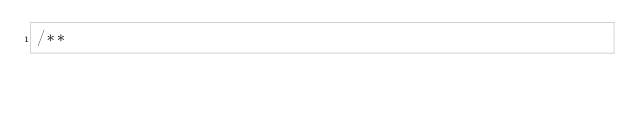Convert code to text. <code><loc_0><loc_0><loc_500><loc_500><_TypeScript_>/**</code> 